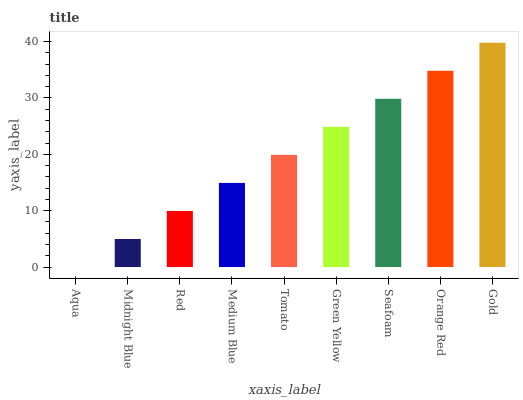Is Midnight Blue the minimum?
Answer yes or no. No. Is Midnight Blue the maximum?
Answer yes or no. No. Is Midnight Blue greater than Aqua?
Answer yes or no. Yes. Is Aqua less than Midnight Blue?
Answer yes or no. Yes. Is Aqua greater than Midnight Blue?
Answer yes or no. No. Is Midnight Blue less than Aqua?
Answer yes or no. No. Is Tomato the high median?
Answer yes or no. Yes. Is Tomato the low median?
Answer yes or no. Yes. Is Midnight Blue the high median?
Answer yes or no. No. Is Midnight Blue the low median?
Answer yes or no. No. 